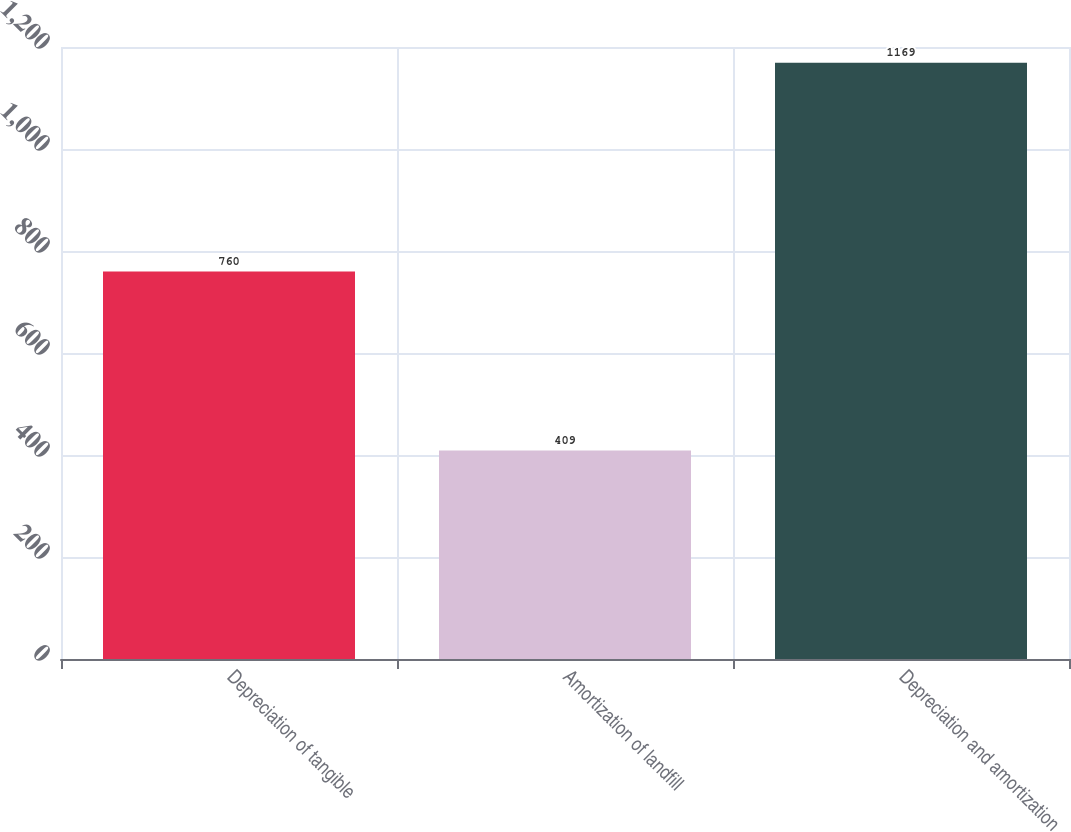<chart> <loc_0><loc_0><loc_500><loc_500><bar_chart><fcel>Depreciation of tangible<fcel>Amortization of landfill<fcel>Depreciation and amortization<nl><fcel>760<fcel>409<fcel>1169<nl></chart> 